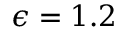<formula> <loc_0><loc_0><loc_500><loc_500>\epsilon = 1 . 2</formula> 